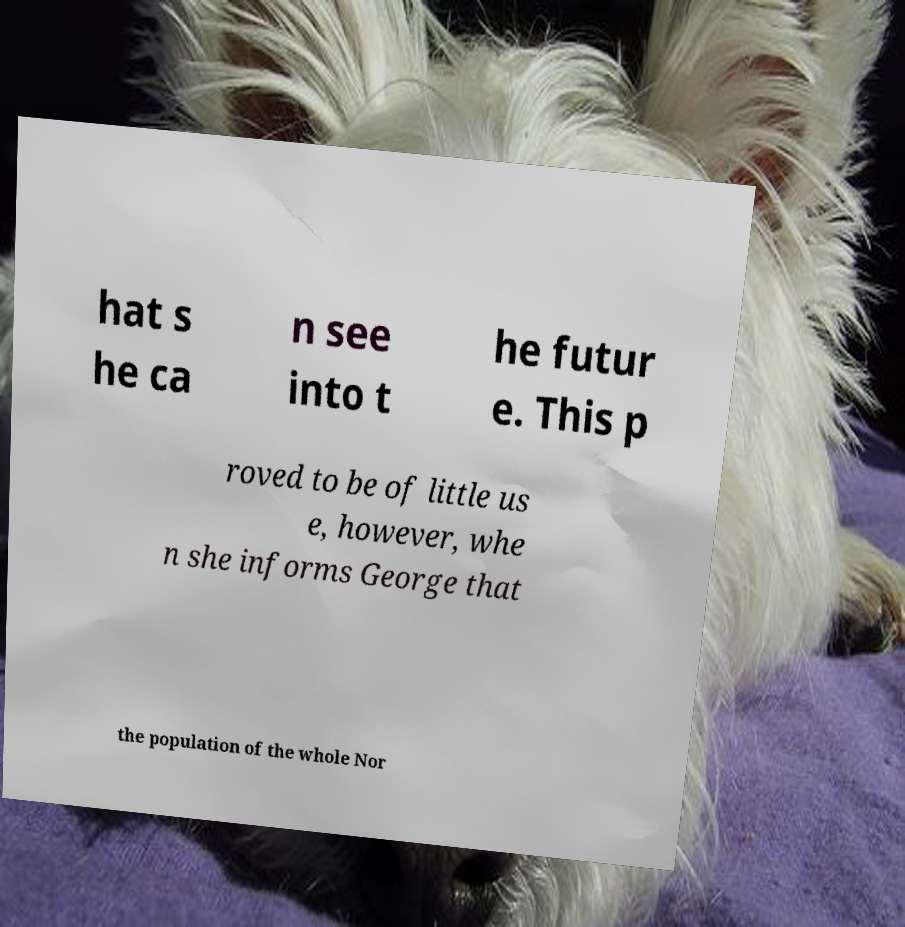What messages or text are displayed in this image? I need them in a readable, typed format. hat s he ca n see into t he futur e. This p roved to be of little us e, however, whe n she informs George that the population of the whole Nor 